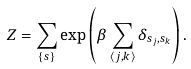Convert formula to latex. <formula><loc_0><loc_0><loc_500><loc_500>Z = \sum _ { \{ s \} } \exp \left ( \beta \sum _ { \langle j , k \rangle } \delta _ { s _ { j } , s _ { k } } \right ) .</formula> 